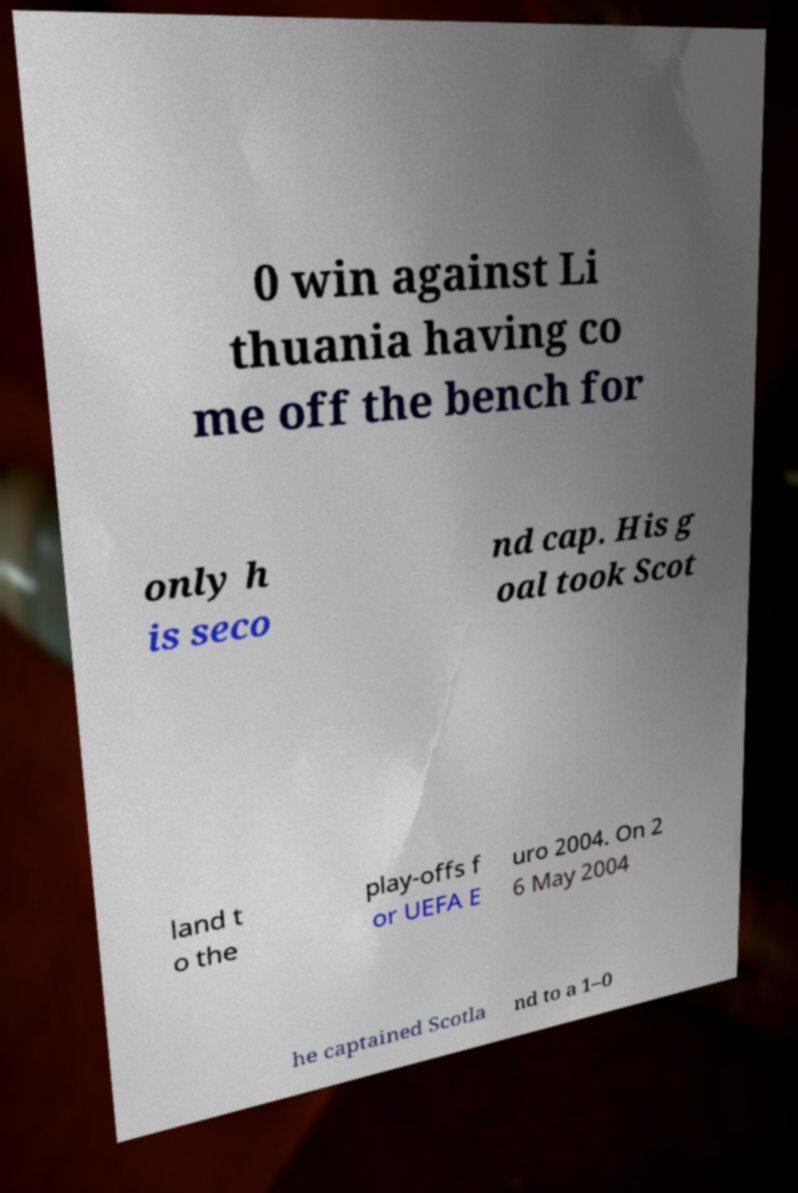Please read and relay the text visible in this image. What does it say? 0 win against Li thuania having co me off the bench for only h is seco nd cap. His g oal took Scot land t o the play-offs f or UEFA E uro 2004. On 2 6 May 2004 he captained Scotla nd to a 1–0 